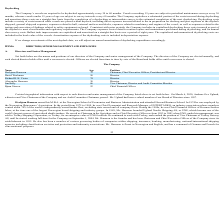From Nordic American Tankers Limited's financial document, Who are the respective chairman and vice chairman of the company? The document shows two values: Herbjørn Hansson and Jim Kelly. From the document: "Herbjørn Hansson 72 Chairman, Chief Executive Officer, President and Director Jim Kelly 66 Vice Chairman, Director and Audit Committee Member..." Also, Who are the company's directors? The document contains multiple relevant values: David Workman, Richard H. K. Vietor, Alexander Hansson, Herbjørn Hansson, Jim Kelly. From the document: "Alexander Hansson 38 Director Jim Kelly 66 Vice Chairman, Director and Audit Committee Member Herbjørn Hansson 72 Chairman, Chief Executive Officer, P..." Also, Who are the company's Chief Executive Officer and Chief Financial Officer? The document shows two values: Herbjørn Hansson and Bjørn Giaever. From the document: "Herbjørn Hansson 72 Chairman, Chief Executive Officer, President and Director Bjørn Giaever 52 Chief Financial Officer..." Also, can you calculate: What is the average age of the company's Chairman and Vice Chairman? To answer this question, I need to perform calculations using the financial data. The calculation is: (72 + 66)/2 , which equals 69. This is based on the information: "Herbjørn Hansson 72 Chairman, Chief Executive Officer, President and Director Jim Kelly 66 Vice Chairman, Director and Audit Committee Member..." The key data points involved are: 66, 72. Also, can you calculate: What is the average age of the company's Chief Executive Officer and Chief Financial Officer? To answer this question, I need to perform calculations using the financial data. The calculation is: (72 + 52)/2 , which equals 62. This is based on the information: "Herbjørn Hansson 72 Chairman, Chief Executive Officer, President and Director Bjørn Giaever 52 Chief Financial Officer..." The key data points involved are: 52, 72. Also, can you calculate: What is the total age of the company's Chief Executive Officer and Chief Financial Officer? Based on the calculation: (72 + 52) , the result is 124. This is based on the information: "Herbjørn Hansson 72 Chairman, Chief Executive Officer, President and Director Bjørn Giaever 52 Chief Financial Officer..." The key data points involved are: 52, 72. 